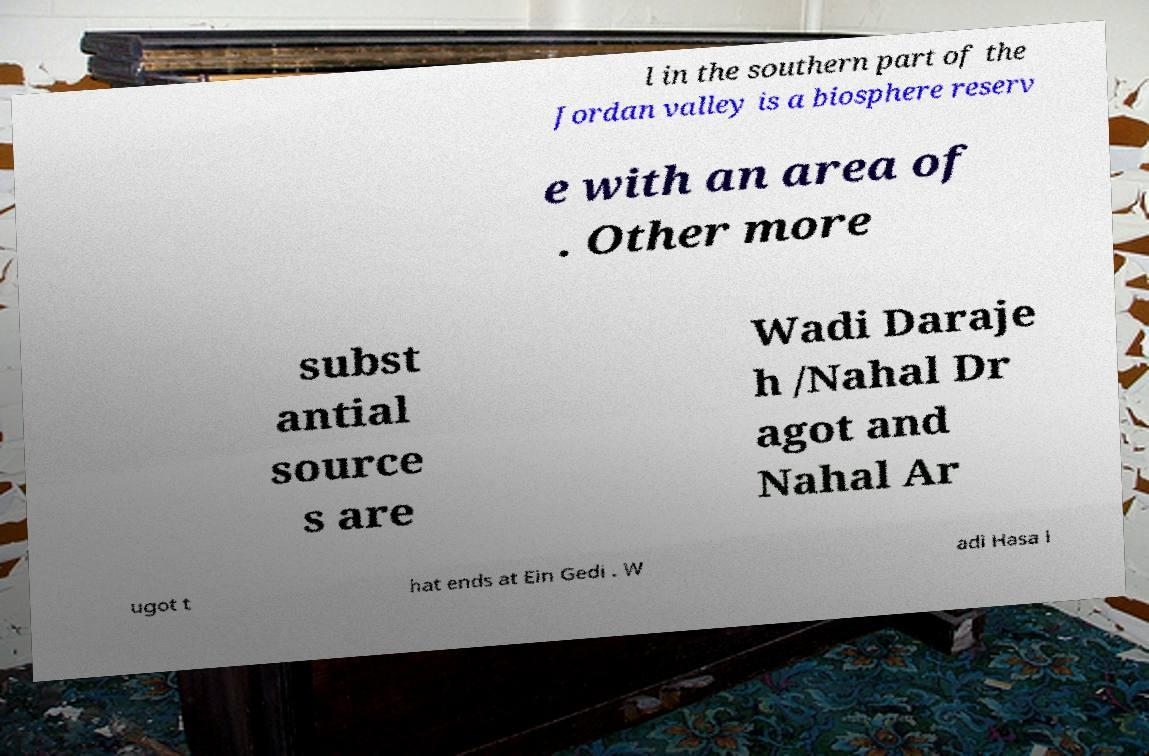Could you assist in decoding the text presented in this image and type it out clearly? l in the southern part of the Jordan valley is a biosphere reserv e with an area of . Other more subst antial source s are Wadi Daraje h /Nahal Dr agot and Nahal Ar ugot t hat ends at Ein Gedi . W adi Hasa i 